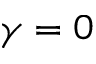Convert formula to latex. <formula><loc_0><loc_0><loc_500><loc_500>\gamma = 0</formula> 